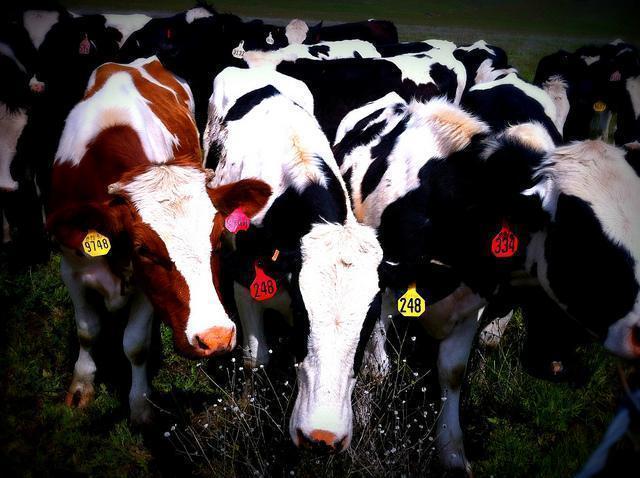What is the largest number on the yellow tags?
Select the correct answer and articulate reasoning with the following format: 'Answer: answer
Rationale: rationale.'
Options: 778, 403, 10562, 9748. Answer: 9748.
Rationale: There are two yellow tags, one is 248 the other is 9748. thousand is a higher number than hundred. What animals have the tags on them?
From the following four choices, select the correct answer to address the question.
Options: Dogs, cats, cows, horses. Cows. 